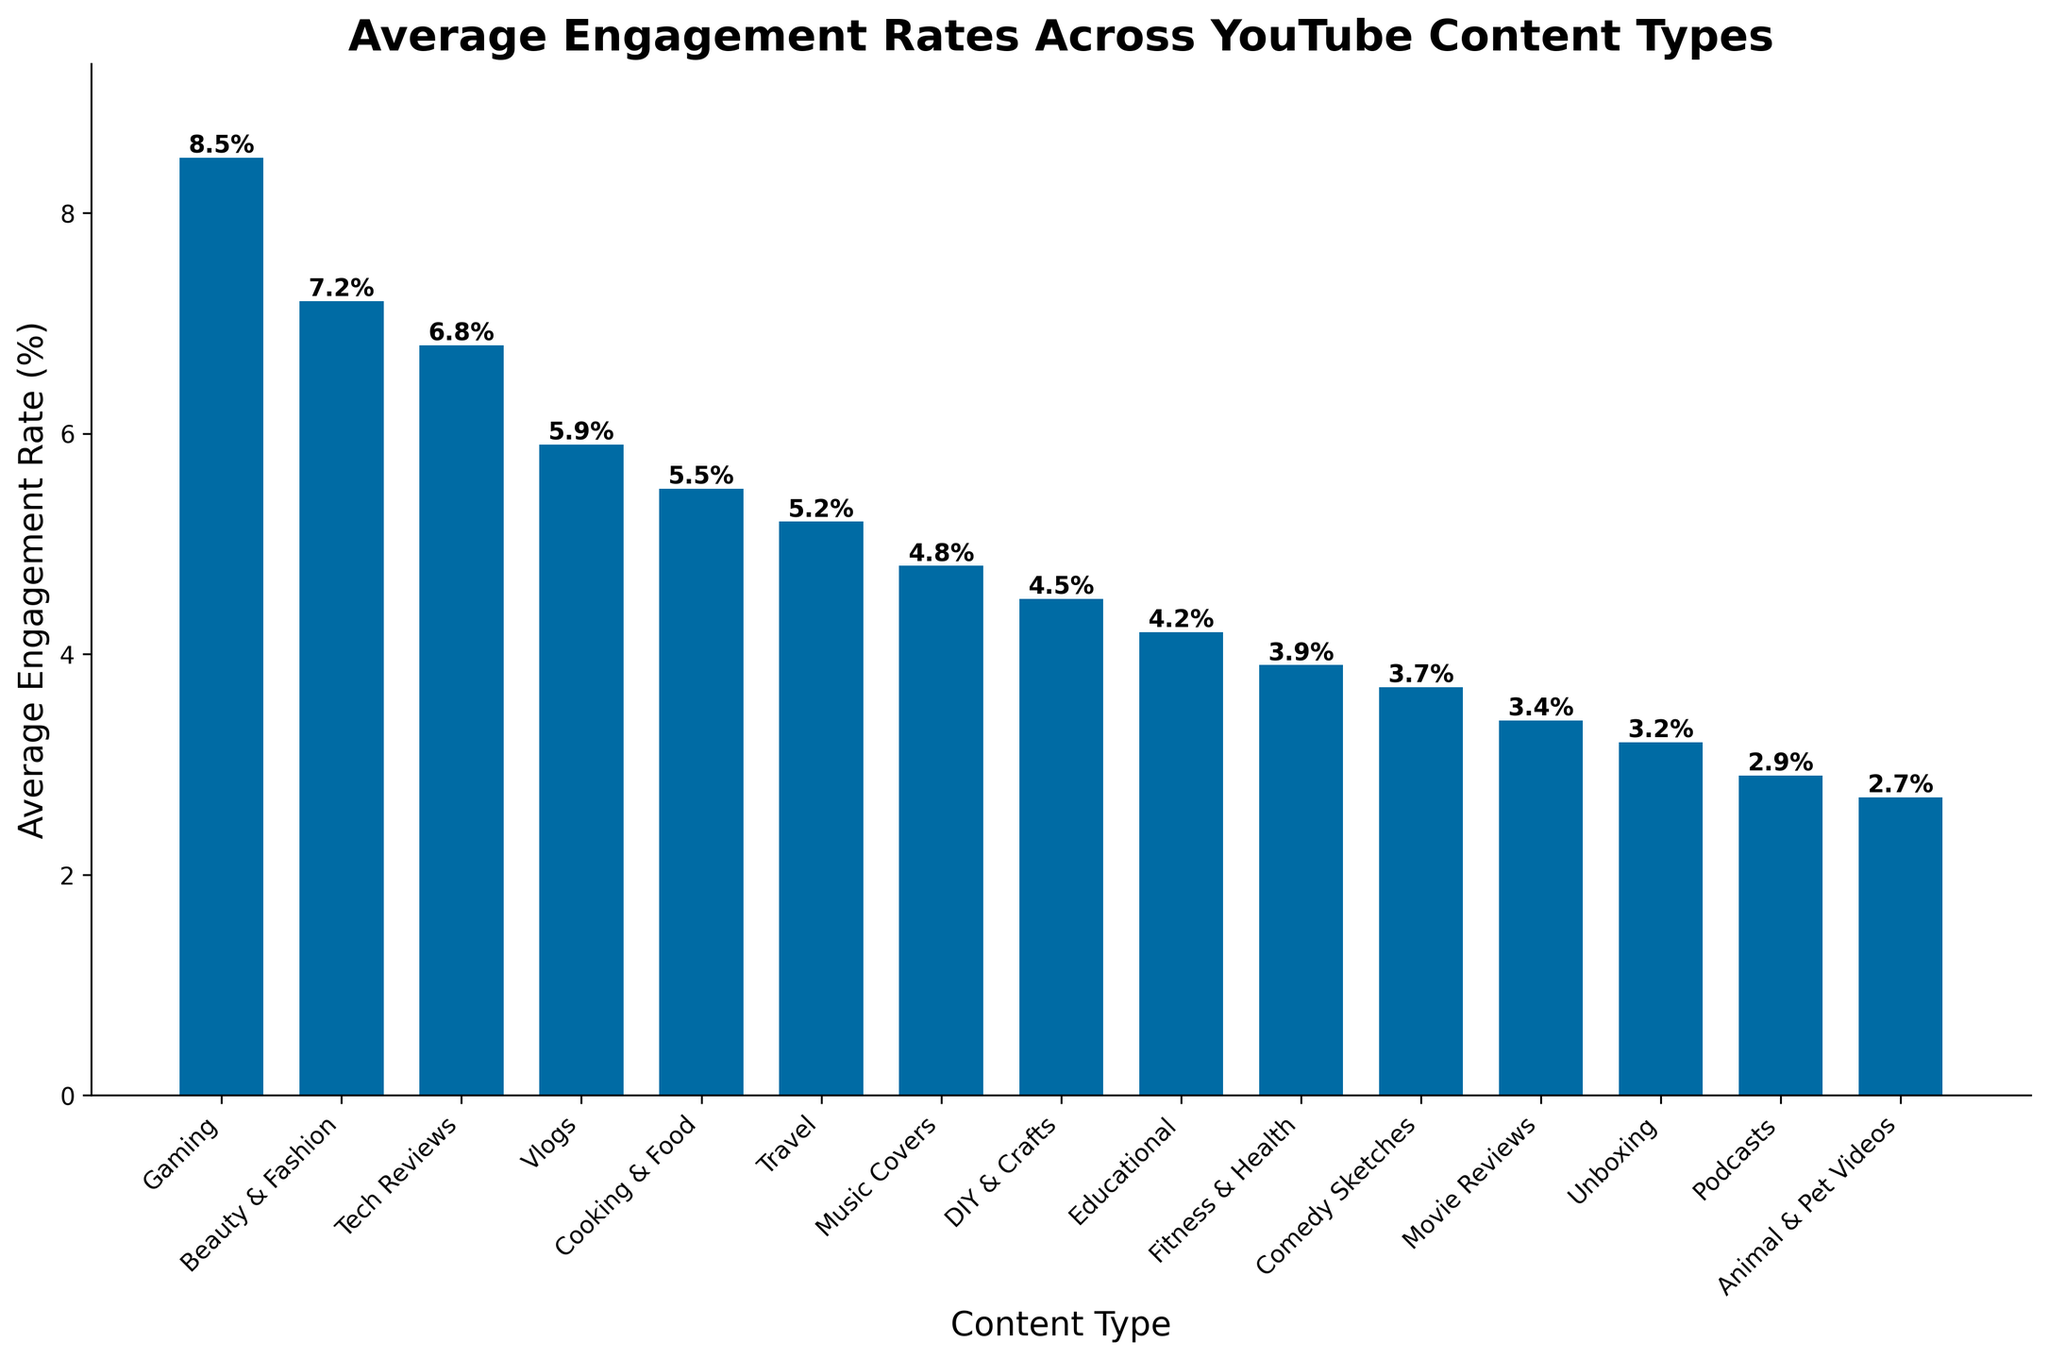What type of YouTube content has the highest average engagement rate? The bar chart shows the engagement rates, and the Gaming category is the tallest bar, indicating the highest engagement rate.
Answer: Gaming How much higher is the average engagement rate for Gaming content compared to Animal & Pet Videos? The average engagement rate for Gaming is 8.5%, and for Animal & Pet Videos, it is 2.7%. The difference is 8.5% - 2.7% = 5.8%.
Answer: 5.8% What types of content have an engagement rate lower than 4%? Observing the chart, content types with bars shorter than the 4% mark are Comedy Sketches, Movie Reviews, Unboxing, Podcasts, and Animal & Pet Videos.
Answer: Comedy Sketches, Movie Reviews, Unboxing, Podcasts, Animal & Pet Videos Which content type has a higher engagement rate: Tech Reviews or Vlogs? Comparing the heights of the bars, Tech Reviews (6.8%) has a higher engagement rate than Vlogs (5.9%).
Answer: Tech Reviews What is the average engagement rate for Beauty & Fashion, Tech Reviews, and Vlogs combined? Add the engagement rates for Beauty & Fashion (7.2%), Tech Reviews (6.8%), and Vlogs (5.9%), then divide by 3. The calculation is (7.2% + 6.8% + 5.9%) / 3 = 6.63%.
Answer: 6.63% Which category has the lowest average engagement rate, and what is its rate? The shortest bar corresponds to Animal & Pet Videos, which has an engagement rate of 2.7%.
Answer: Animal & Pet Videos, 2.7% Are any content types' engagement rates exactly equal to each other? Observing the bar chart, no two bars have the exact same height, so no two content types have identical engagement rates.
Answer: No How many content types have an engagement rate higher than 5%? Counting the bars taller than the 5% mark: Gaming, Beauty & Fashion, Tech Reviews, and Vlogs, Cooking & Food.
Answer: 5 What's the median engagement rate, and which content type(s) is closest to this value? Listing the rates in order: Animal & Pet Videos (2.7%), Podcasts (2.9%), Unboxing (3.2%), Movie Reviews (3.4%), Comedy Sketches (3.7%), Fitness & Health (3.9%), Educational (4.2%), DIY & Crafts (4.5%), Music Covers (4.8%), Travel (5.2%), Cooking & Food (5.5%), Vlogs (5.9%), Tech Reviews (6.8%), Beauty & Fashion (7.2%), Gaming (8.5%). The median (middle value) is Fitness & Health (3.9%).
Answer: Fitness & Health (3.9%) What is the difference in engagement rate between the highest and lowest content types? The highest engagement rate is Gaming (8.5%), and the lowest is Animal & Pet Videos (2.7%). The difference is 8.5% - 2.7% = 5.8%.
Answer: 5.8% 